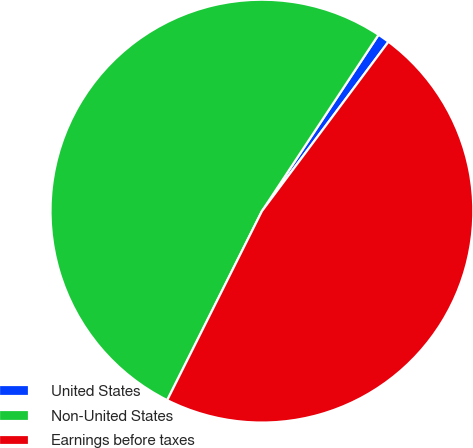<chart> <loc_0><loc_0><loc_500><loc_500><pie_chart><fcel>United States<fcel>Non-United States<fcel>Earnings before taxes<nl><fcel>0.91%<fcel>51.9%<fcel>47.18%<nl></chart> 